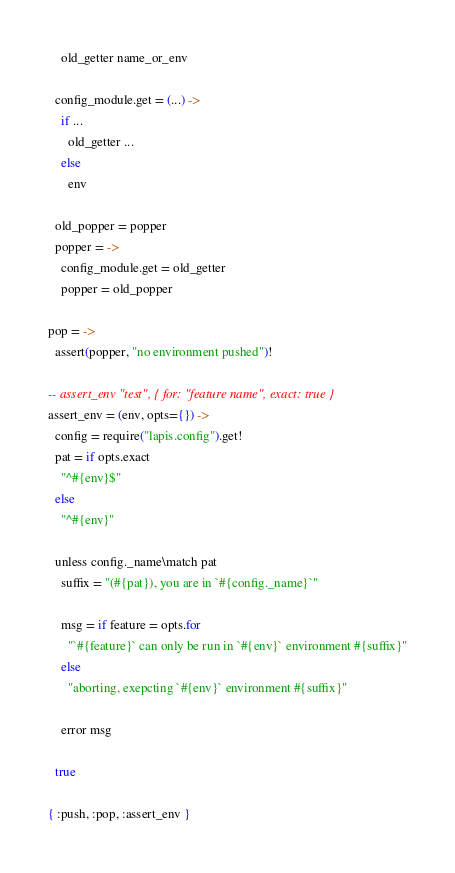Convert code to text. <code><loc_0><loc_0><loc_500><loc_500><_MoonScript_>    old_getter name_or_env

  config_module.get = (...) ->
    if ...
      old_getter ...
    else
      env

  old_popper = popper
  popper = ->
    config_module.get = old_getter
    popper = old_popper

pop = ->
  assert(popper, "no environment pushed")!

-- assert_env "test", { for: "feature name", exact: true }
assert_env = (env, opts={}) ->
  config = require("lapis.config").get!
  pat = if opts.exact
    "^#{env}$"
  else
    "^#{env}"

  unless config._name\match pat
    suffix = "(#{pat}), you are in `#{config._name}`"

    msg = if feature = opts.for
      "`#{feature}` can only be run in `#{env}` environment #{suffix}"
    else
      "aborting, exepcting `#{env}` environment #{suffix}"

    error msg

  true

{ :push, :pop, :assert_env }
</code> 